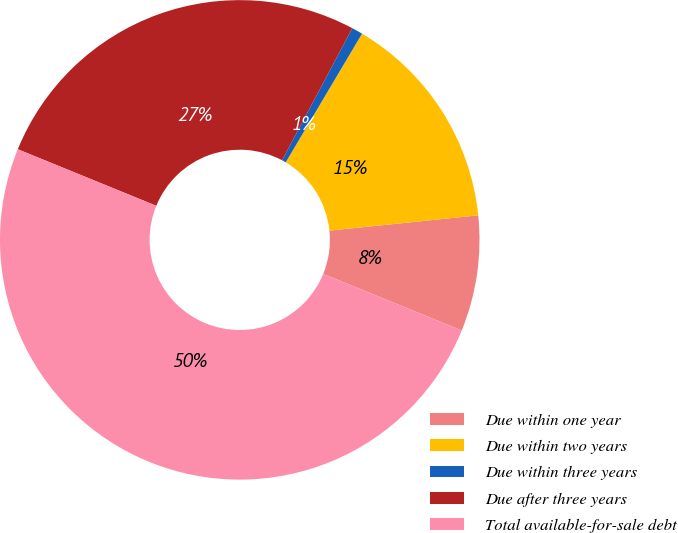Convert chart. <chart><loc_0><loc_0><loc_500><loc_500><pie_chart><fcel>Due within one year<fcel>Due within two years<fcel>Due within three years<fcel>Due after three years<fcel>Total available-for-sale debt<nl><fcel>7.8%<fcel>14.85%<fcel>0.74%<fcel>26.61%<fcel>50.0%<nl></chart> 